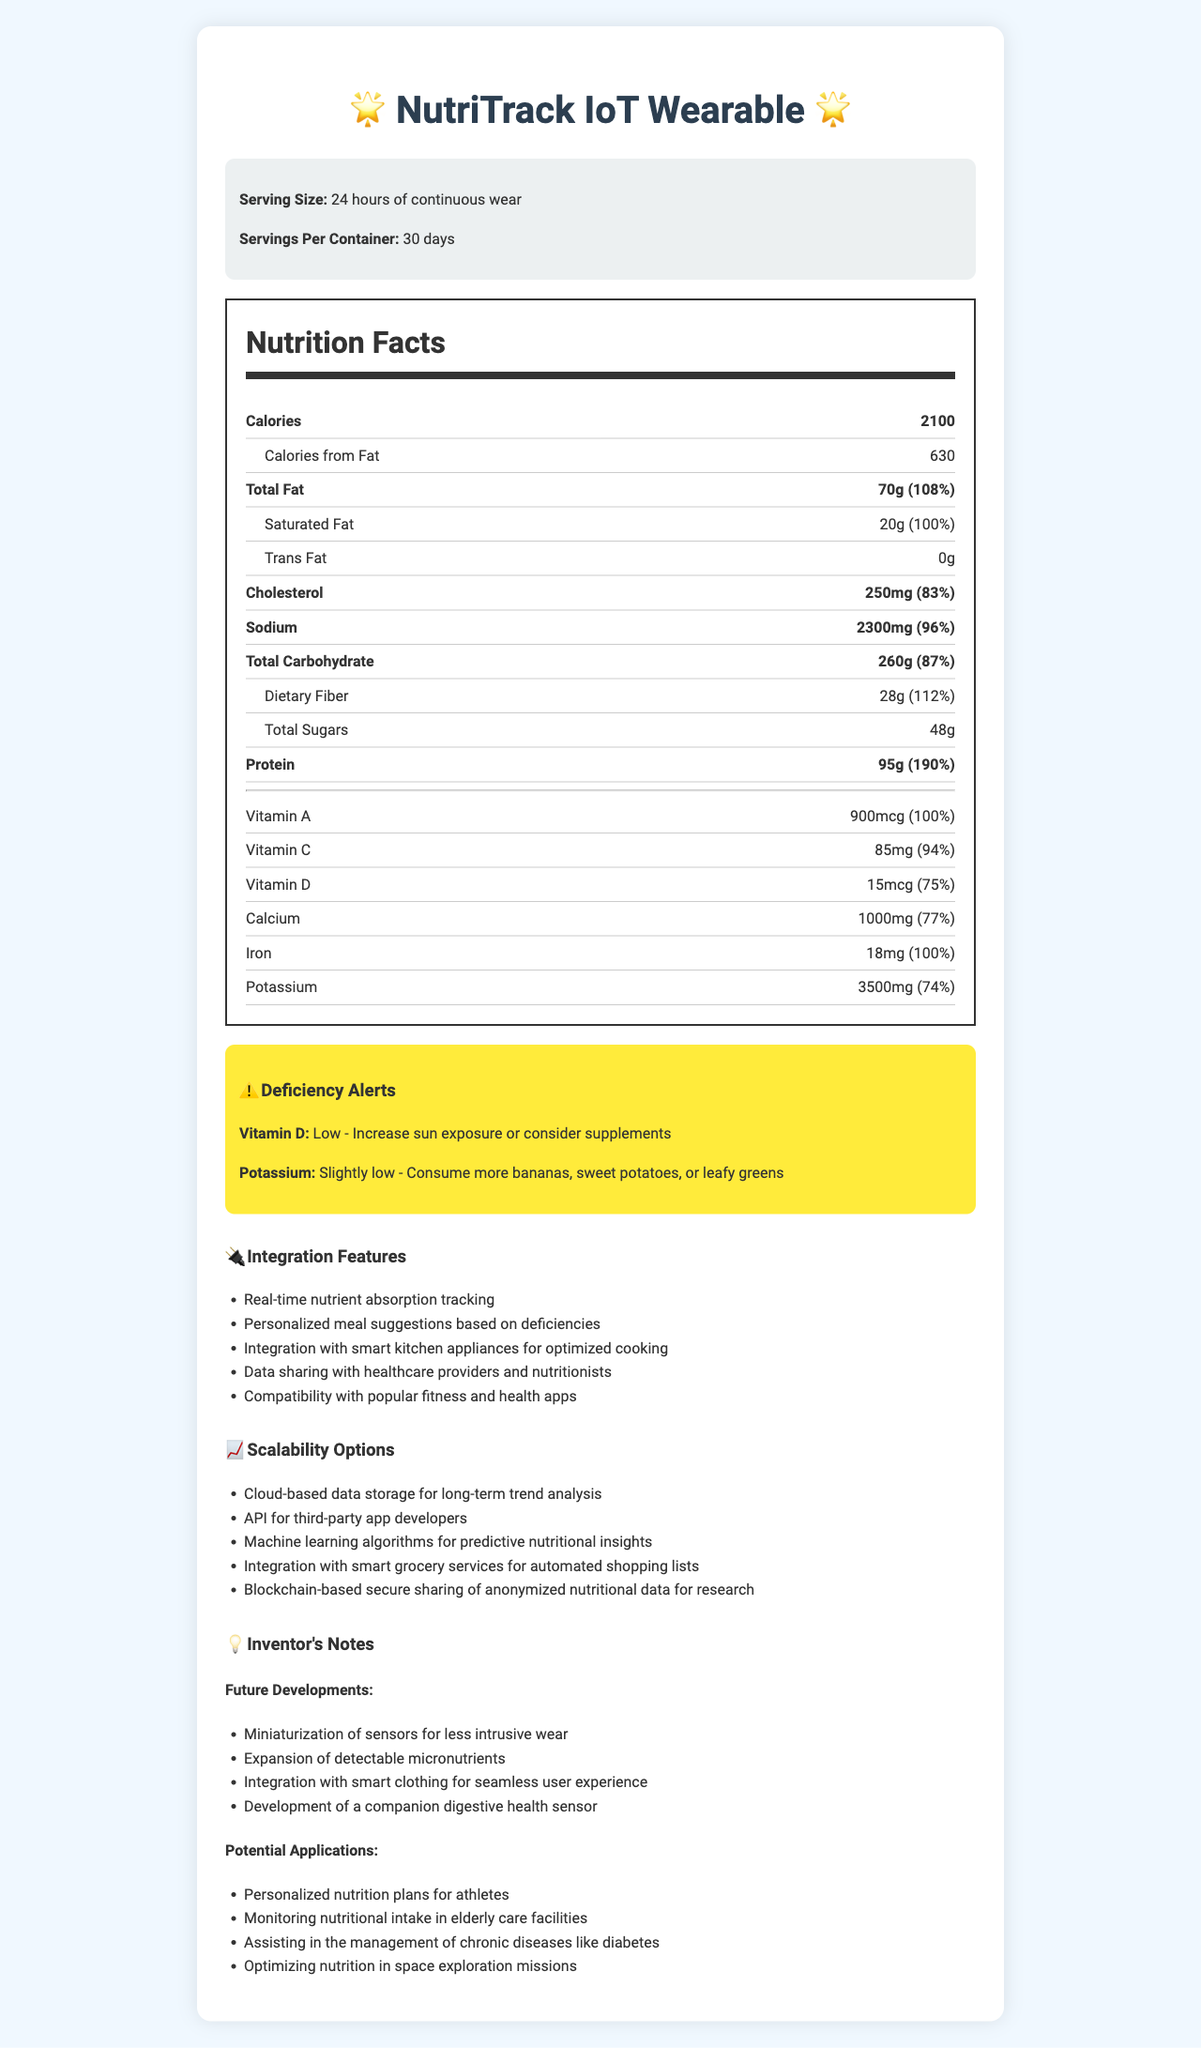who is the product designed for? The document specifies the "NutriTrack IoT Wearable" and its properties, which indicate it is designed for individuals aiming to monitor their daily nutrient absorption.
Answer: Individuals looking to track their nutrient intake how many calories does the wearable track from fat? The document lists that out of the total 2100 calories, 630 calories are from fat.
Answer: 630 calories what is the serving size mentioned in the document? The serving size is specified as "24 hours of continuous wear".
Answer: 24 hours of continuous wear how many servings per container does the document indicate? The document states that there are "30 days" of servings per container.
Answer: 30 days which nutrient has a 'Low' deficiency alert? The deficiency alerts indicate that Vitamin D has a "Low" status and provides a recommendation for increasing intake.
Answer: Vitamin D which of the following nutrients has the highest percent daily value absorption? A. Total Fat B. Sodium C. Protein The absorption rate for protein is 190%, which is the highest among the listed nutrients.
Answer: C. Protein what is the amount of dietary fiber absorbed daily according to the document? A. 20g B. 28g C. 48g D. 95g The daily absorption for dietary fiber is indicated as 28g.
Answer: B. 28g does the document provide data on total sugars absorption? The document lists "48g" of total sugars under daily nutrient absorption.
Answer: Yes what features does the device offer for integration? The integration features section lists all these functionalities.
Answer: Real-time nutrient absorption tracking, Personalized meal suggestions, Integration with smart kitchen appliances, Data sharing with healthcare providers, Compatibility with popular fitness apps what are some of the potential future developments mentioned? The inventors' notes list these as future developments.
Answer: Miniaturization of sensors, Expansion of detectable micronutrients, Integration with smart clothing, Development of a companion digestive health sensor how does the device help with potassium deficiency? The deficiency alert for potassium suggests dietary recommendations to increase potassium intake.
Answer: Consume more bananas, sweet potatoes, or leafy greens describe the overall purpose of the "NutriTrack IoT Wearable" as presented in the document. The document details the device's features, its deficiency alerts, integration capabilities, and future development plans, emphasizing its use in monitoring and managing nutrient intake.
Answer: The NutriTrack IoT Wearable is designed to monitor daily nutrient absorption, notify users about micronutrient deficiencies, and integrate with various health and fitness systems to provide personalized nutritional insights and improve overall dietary management. is it possible to determine the R&D budget for the NutriTrack device from the document? The document does not contain any financial details or budgetary information regarding the development of the NutriTrack IoT Wearable.
Answer: Not enough information 